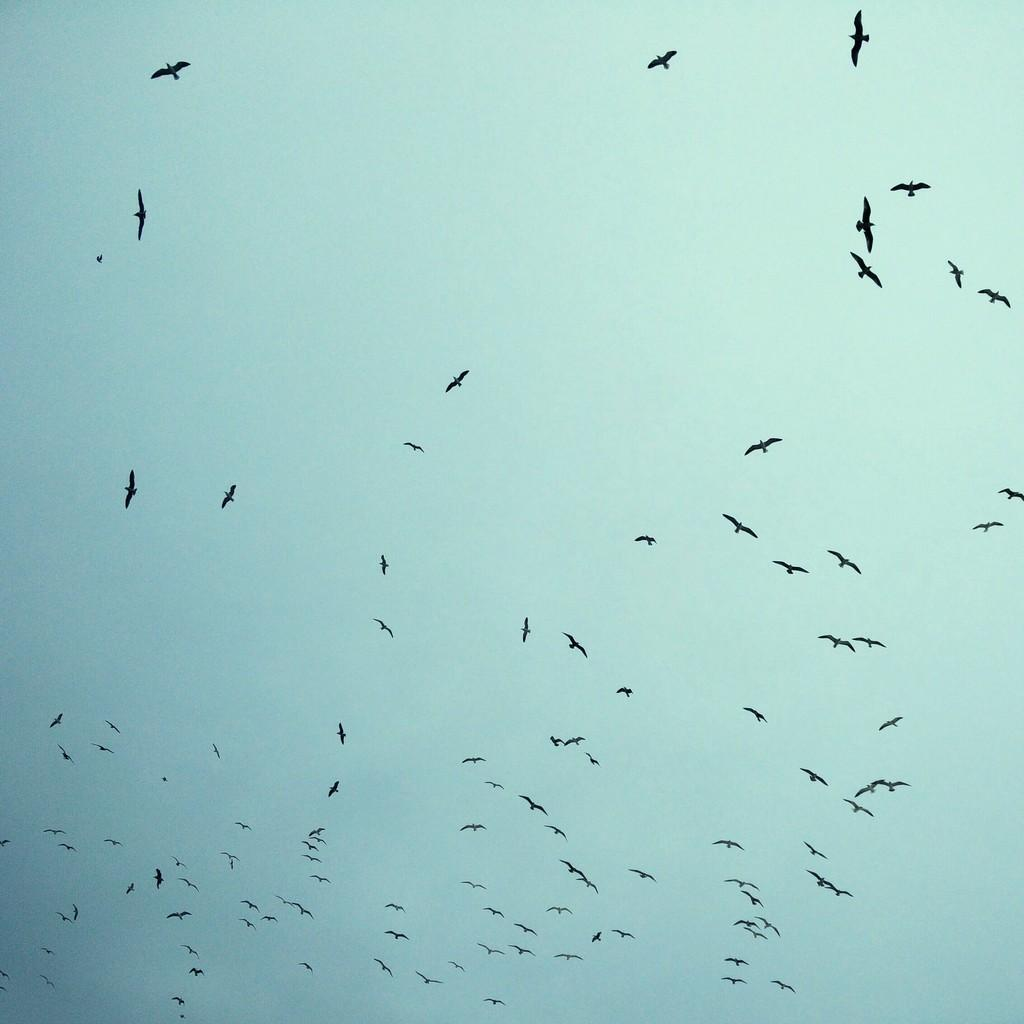What is happening in the sky in the image? There are birds flying in the sky. What is the condition of the sky in the image? The sky is clear in the image. What type of jar can be seen holding a letter in the image? There is no jar or letter present in the image; it only features birds flying in the sky. How many apples are visible in the image? There are no apples present in the image. 